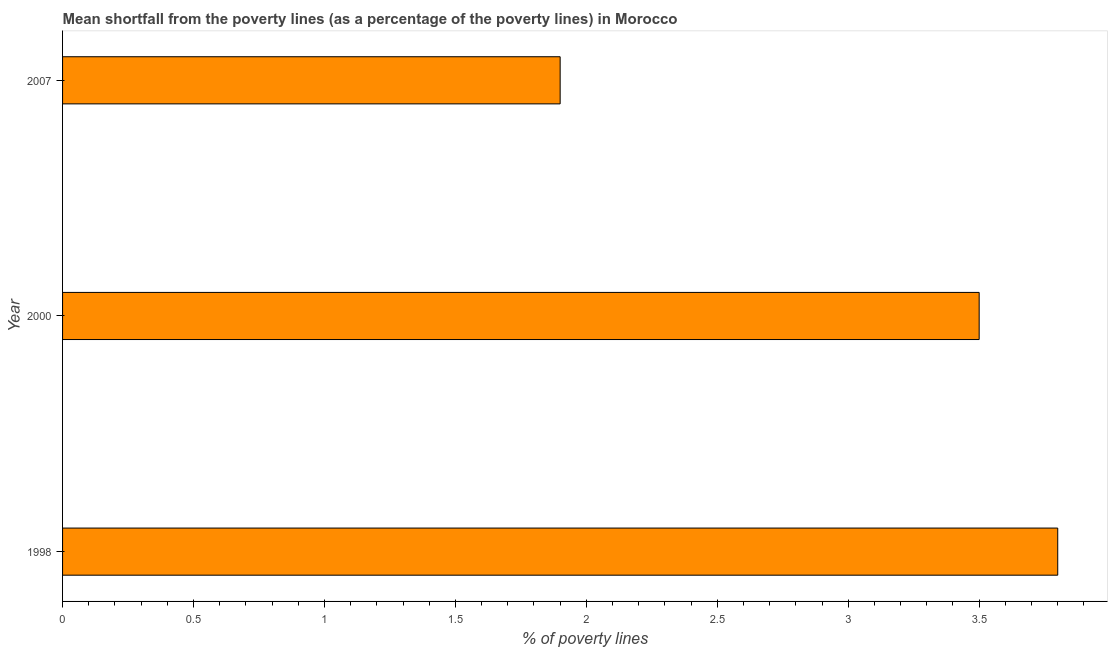Does the graph contain any zero values?
Ensure brevity in your answer.  No. Does the graph contain grids?
Offer a very short reply. No. What is the title of the graph?
Provide a succinct answer. Mean shortfall from the poverty lines (as a percentage of the poverty lines) in Morocco. What is the label or title of the X-axis?
Offer a very short reply. % of poverty lines. What is the label or title of the Y-axis?
Your answer should be compact. Year. Across all years, what is the maximum poverty gap at national poverty lines?
Offer a terse response. 3.8. In which year was the poverty gap at national poverty lines maximum?
Give a very brief answer. 1998. In which year was the poverty gap at national poverty lines minimum?
Give a very brief answer. 2007. What is the sum of the poverty gap at national poverty lines?
Offer a very short reply. 9.2. What is the difference between the poverty gap at national poverty lines in 1998 and 2007?
Offer a terse response. 1.9. What is the average poverty gap at national poverty lines per year?
Offer a terse response. 3.07. What is the median poverty gap at national poverty lines?
Your answer should be compact. 3.5. Do a majority of the years between 2000 and 2007 (inclusive) have poverty gap at national poverty lines greater than 3.5 %?
Keep it short and to the point. No. What is the ratio of the poverty gap at national poverty lines in 1998 to that in 2000?
Offer a very short reply. 1.09. Is the poverty gap at national poverty lines in 1998 less than that in 2007?
Give a very brief answer. No. What is the difference between the highest and the second highest poverty gap at national poverty lines?
Give a very brief answer. 0.3. Is the sum of the poverty gap at national poverty lines in 2000 and 2007 greater than the maximum poverty gap at national poverty lines across all years?
Offer a very short reply. Yes. How many years are there in the graph?
Offer a very short reply. 3. What is the % of poverty lines in 1998?
Provide a short and direct response. 3.8. What is the % of poverty lines in 2000?
Offer a terse response. 3.5. What is the % of poverty lines of 2007?
Keep it short and to the point. 1.9. What is the difference between the % of poverty lines in 1998 and 2007?
Keep it short and to the point. 1.9. What is the ratio of the % of poverty lines in 1998 to that in 2000?
Keep it short and to the point. 1.09. What is the ratio of the % of poverty lines in 2000 to that in 2007?
Provide a succinct answer. 1.84. 